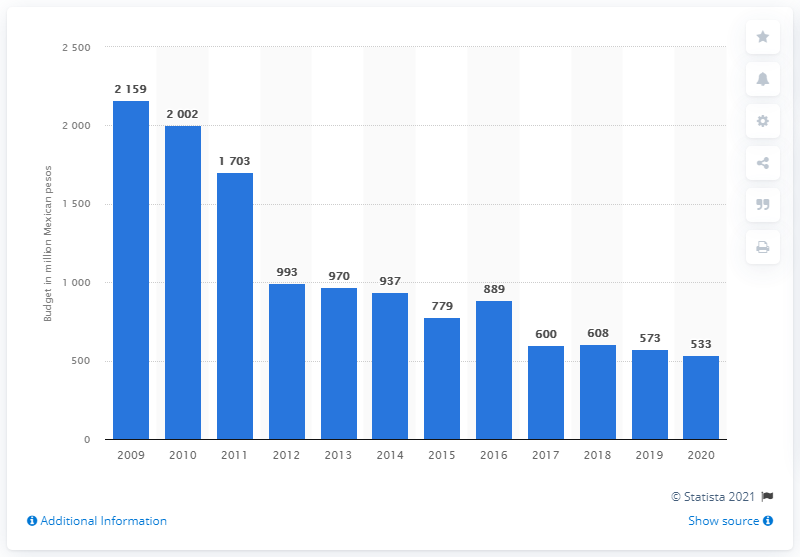Indicate a few pertinent items in this graphic. The budget for the 2009 swine flu epidemic was 2159. The 2020 budget of the Secretariat of Health in Mexico was approximately 533 million pesos. 